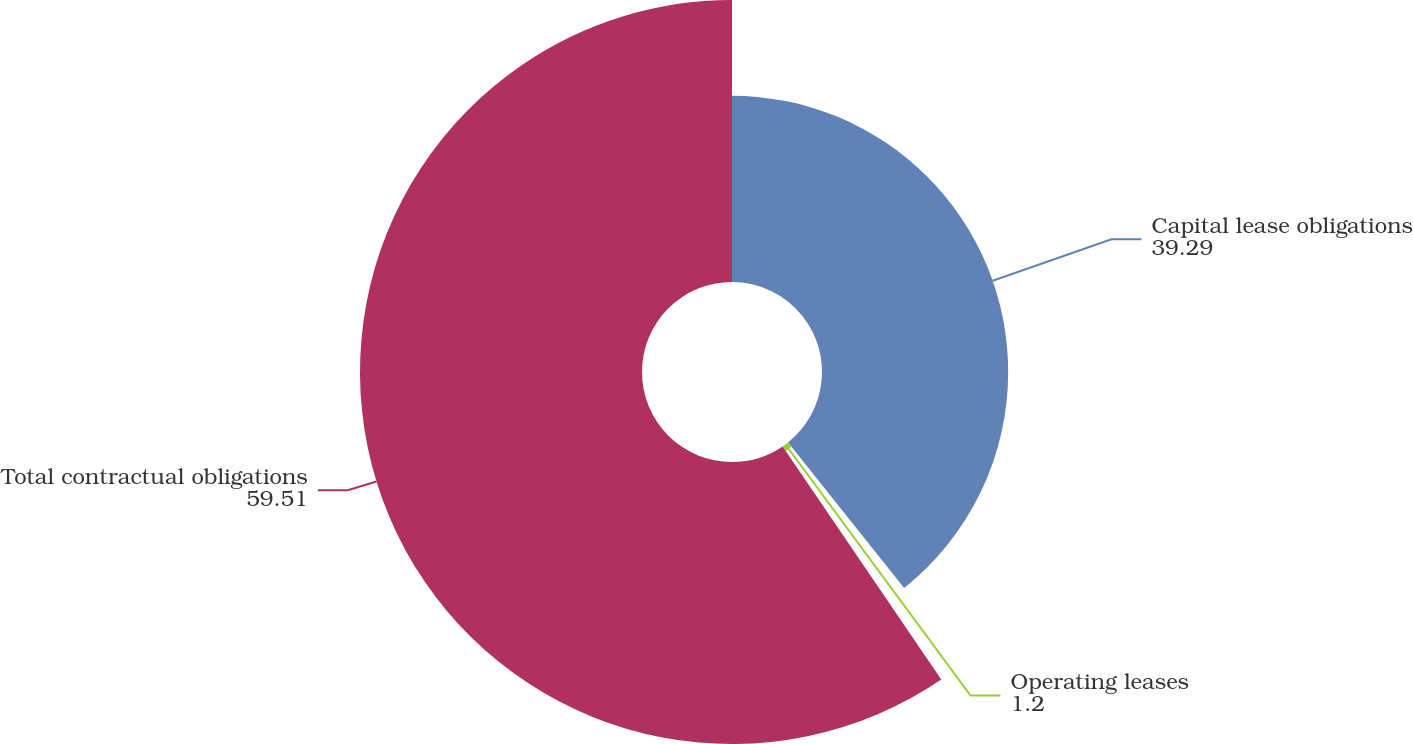Convert chart to OTSL. <chart><loc_0><loc_0><loc_500><loc_500><pie_chart><fcel>Capital lease obligations<fcel>Operating leases<fcel>Total contractual obligations<nl><fcel>39.29%<fcel>1.2%<fcel>59.51%<nl></chart> 